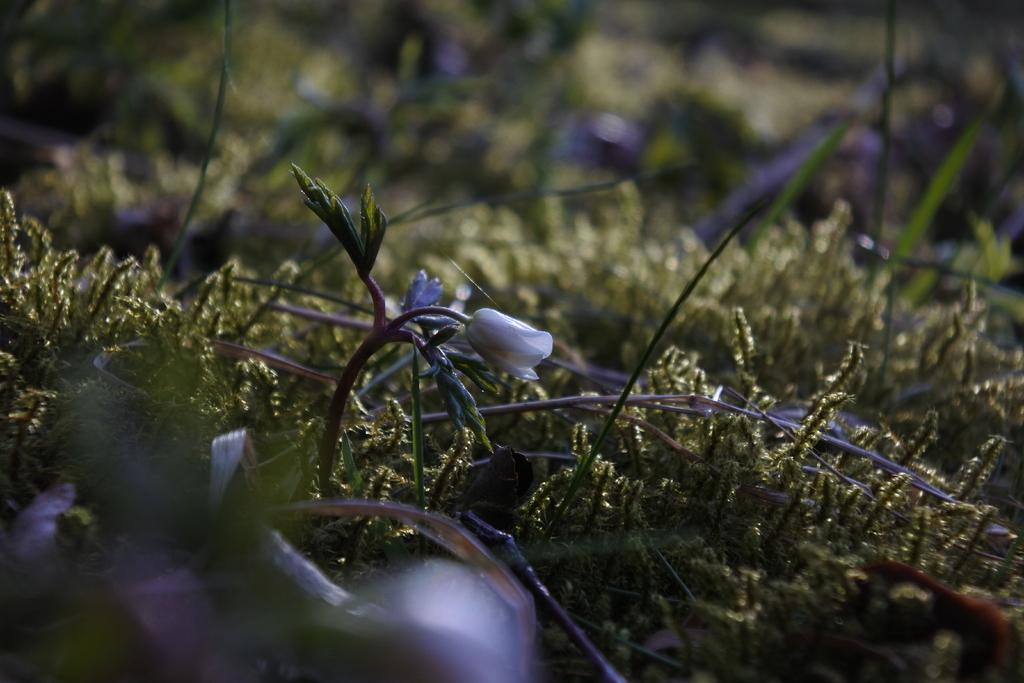What type of flower is present in the image? There is a white color flower in the image. What else can be seen in the image besides the flower? There is a plant in the image. What is the color of the grass on the ground in the image? The grass on the ground in the image is green-colored. Can you tell me how many lawyers are present in the image? There are no lawyers present in the image; it features a white color flower, a plant, and green-colored grass. 